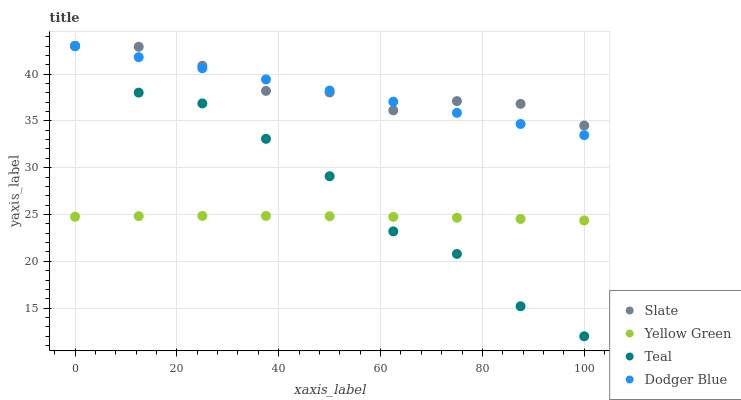Does Yellow Green have the minimum area under the curve?
Answer yes or no. Yes. Does Slate have the maximum area under the curve?
Answer yes or no. Yes. Does Dodger Blue have the minimum area under the curve?
Answer yes or no. No. Does Dodger Blue have the maximum area under the curve?
Answer yes or no. No. Is Dodger Blue the smoothest?
Answer yes or no. Yes. Is Teal the roughest?
Answer yes or no. Yes. Is Yellow Green the smoothest?
Answer yes or no. No. Is Yellow Green the roughest?
Answer yes or no. No. Does Teal have the lowest value?
Answer yes or no. Yes. Does Dodger Blue have the lowest value?
Answer yes or no. No. Does Teal have the highest value?
Answer yes or no. Yes. Does Yellow Green have the highest value?
Answer yes or no. No. Is Yellow Green less than Dodger Blue?
Answer yes or no. Yes. Is Slate greater than Yellow Green?
Answer yes or no. Yes. Does Slate intersect Teal?
Answer yes or no. Yes. Is Slate less than Teal?
Answer yes or no. No. Is Slate greater than Teal?
Answer yes or no. No. Does Yellow Green intersect Dodger Blue?
Answer yes or no. No. 